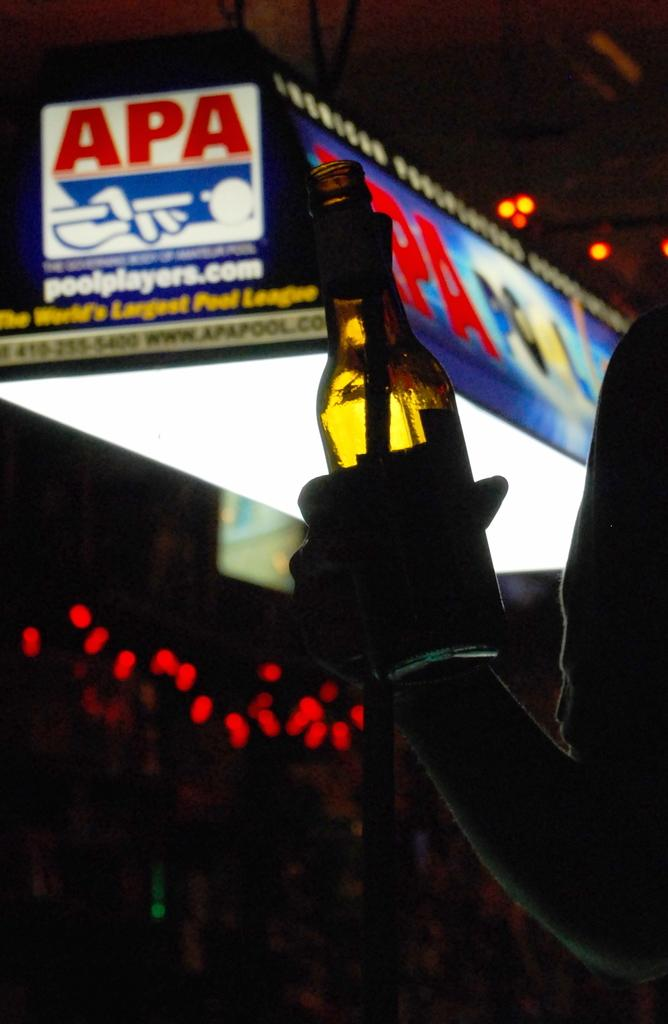Who or what is present in the image? There is a person in the image. What is the person holding in his hand? The person is holding a glass bottle in his hand. What can be seen in the background of the image? There is a board visible in the background of the image. What type of cup is the person using to rub the board in the image? There is no cup present in the image, and the person is not rubbing the board. 